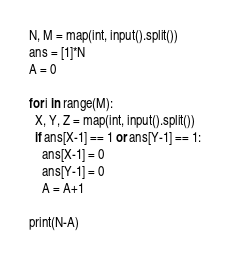<code> <loc_0><loc_0><loc_500><loc_500><_Python_>N, M = map(int, input().split())
ans = [1]*N
A = 0

for i in range(M):
  X, Y, Z = map(int, input().split())
  if ans[X-1] == 1 or ans[Y-1] == 1:
    ans[X-1] = 0
    ans[Y-1] = 0
    A = A+1

print(N-A)</code> 